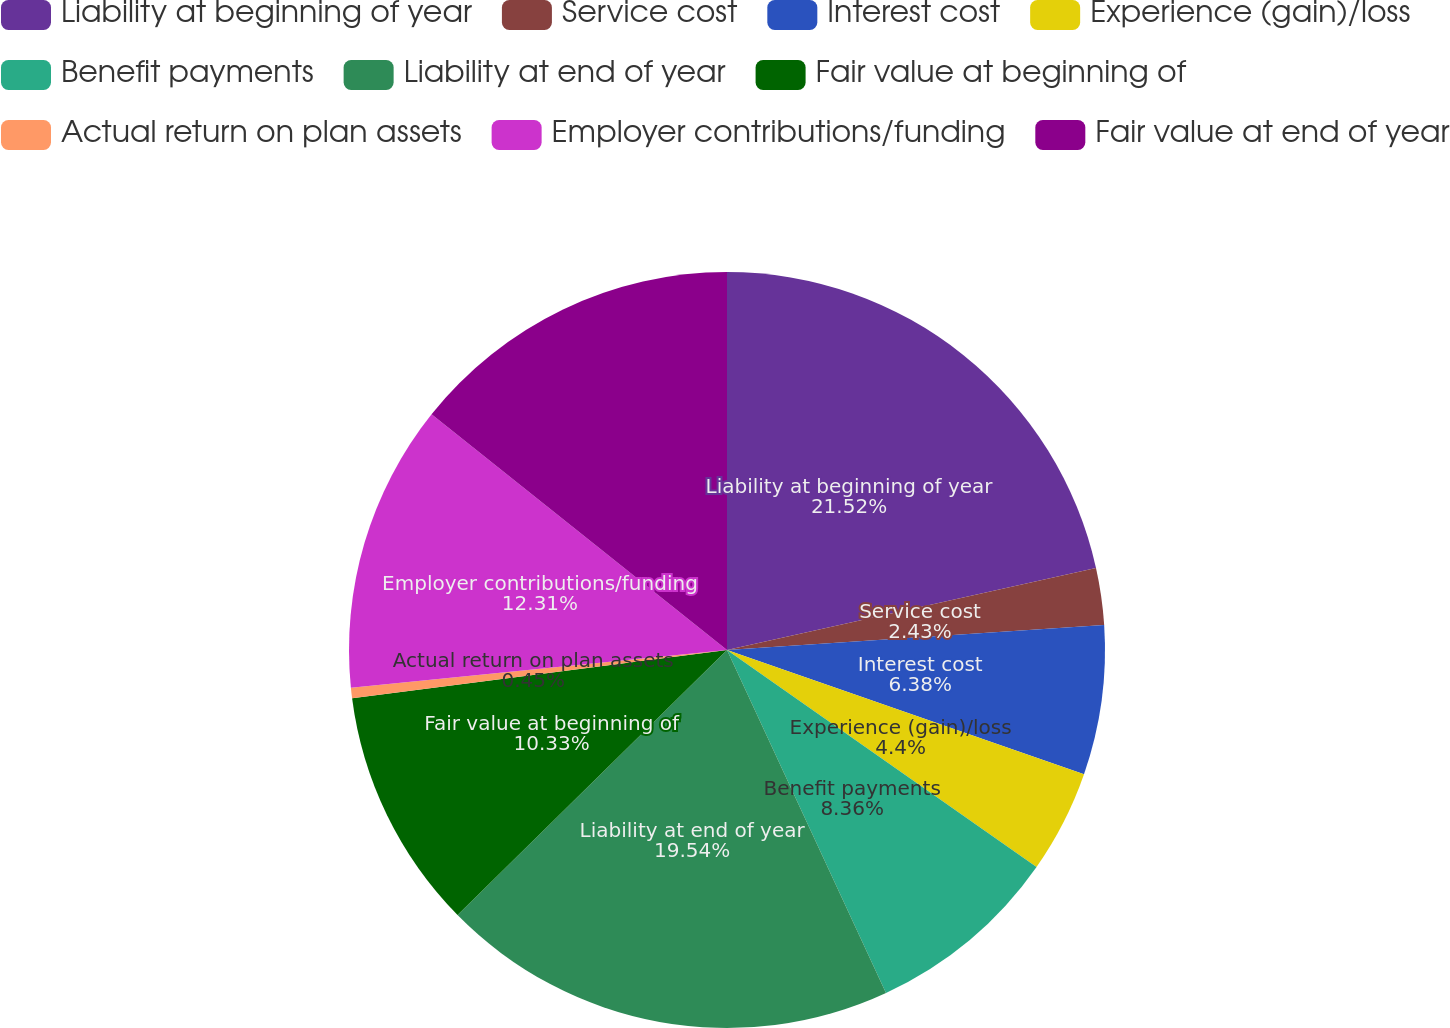<chart> <loc_0><loc_0><loc_500><loc_500><pie_chart><fcel>Liability at beginning of year<fcel>Service cost<fcel>Interest cost<fcel>Experience (gain)/loss<fcel>Benefit payments<fcel>Liability at end of year<fcel>Fair value at beginning of<fcel>Actual return on plan assets<fcel>Employer contributions/funding<fcel>Fair value at end of year<nl><fcel>21.52%<fcel>2.43%<fcel>6.38%<fcel>4.4%<fcel>8.36%<fcel>19.54%<fcel>10.33%<fcel>0.45%<fcel>12.31%<fcel>14.28%<nl></chart> 